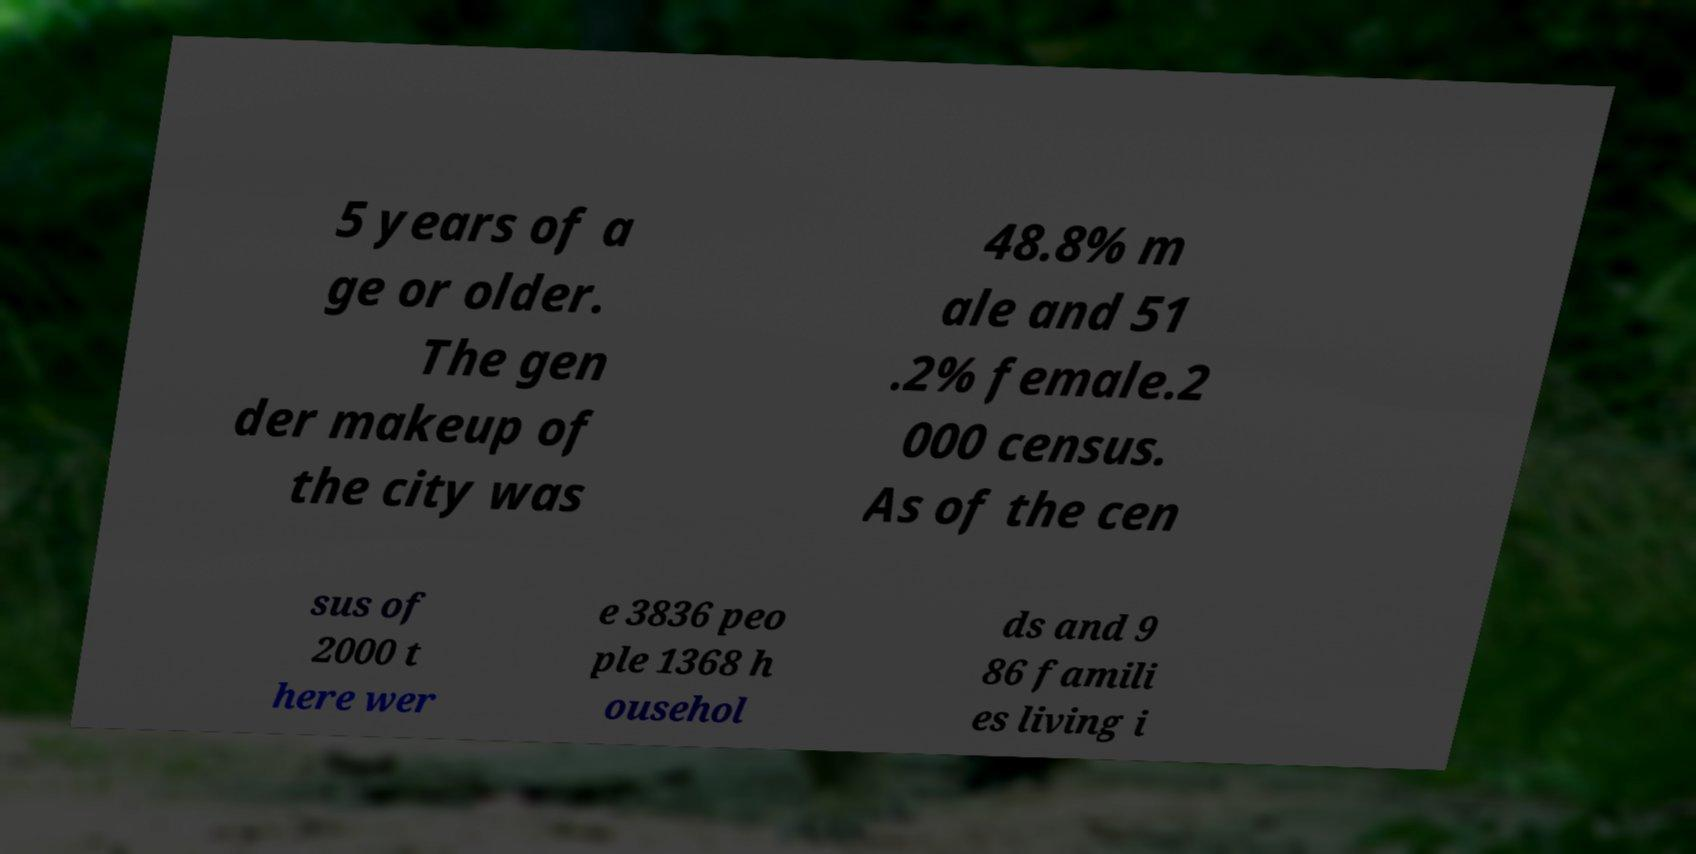Please identify and transcribe the text found in this image. 5 years of a ge or older. The gen der makeup of the city was 48.8% m ale and 51 .2% female.2 000 census. As of the cen sus of 2000 t here wer e 3836 peo ple 1368 h ousehol ds and 9 86 famili es living i 